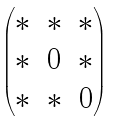<formula> <loc_0><loc_0><loc_500><loc_500>\begin{pmatrix} \ast & \ast & \ast \\ \ast & 0 & \ast \\ \ast & \ast & 0 \end{pmatrix}</formula> 